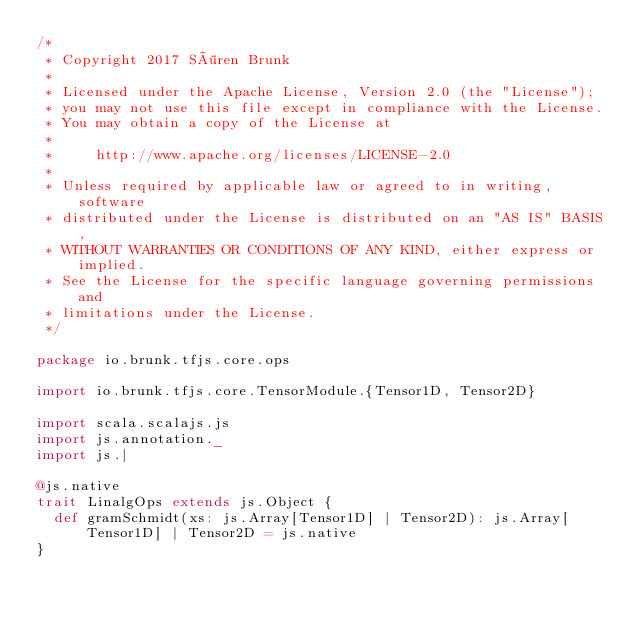Convert code to text. <code><loc_0><loc_0><loc_500><loc_500><_Scala_>/*
 * Copyright 2017 Sören Brunk
 *
 * Licensed under the Apache License, Version 2.0 (the "License");
 * you may not use this file except in compliance with the License.
 * You may obtain a copy of the License at
 *
 *     http://www.apache.org/licenses/LICENSE-2.0
 *
 * Unless required by applicable law or agreed to in writing, software
 * distributed under the License is distributed on an "AS IS" BASIS,
 * WITHOUT WARRANTIES OR CONDITIONS OF ANY KIND, either express or implied.
 * See the License for the specific language governing permissions and
 * limitations under the License.
 */

package io.brunk.tfjs.core.ops

import io.brunk.tfjs.core.TensorModule.{Tensor1D, Tensor2D}

import scala.scalajs.js
import js.annotation._
import js.|

@js.native
trait LinalgOps extends js.Object {
  def gramSchmidt(xs: js.Array[Tensor1D] | Tensor2D): js.Array[Tensor1D] | Tensor2D = js.native
}
</code> 